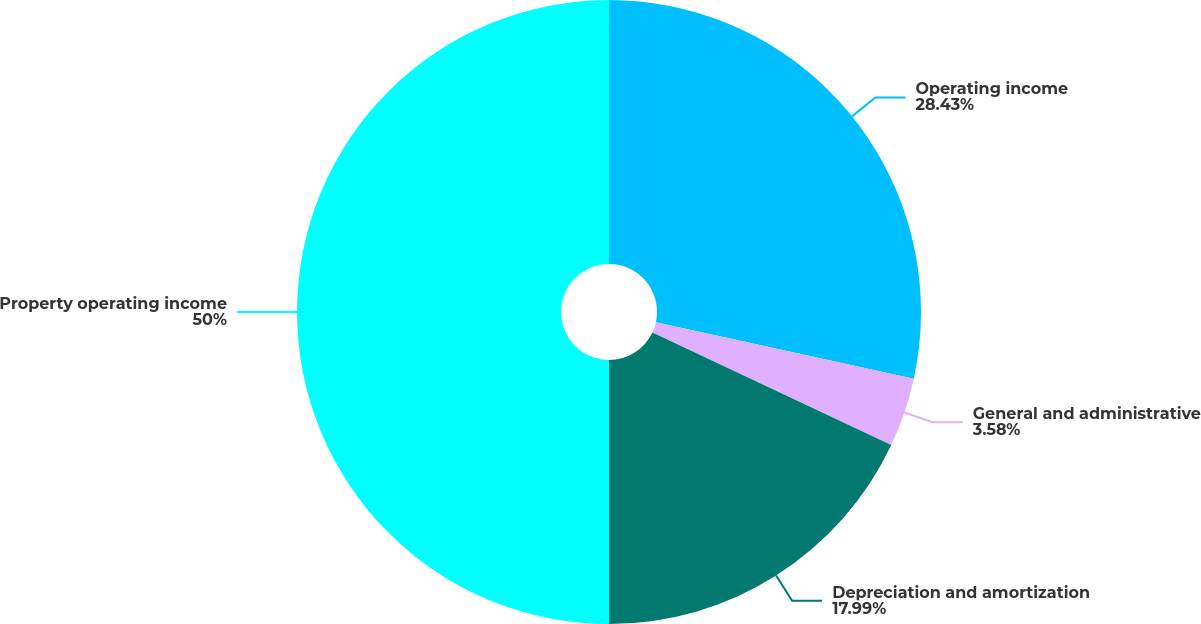Convert chart to OTSL. <chart><loc_0><loc_0><loc_500><loc_500><pie_chart><fcel>Operating income<fcel>General and administrative<fcel>Depreciation and amortization<fcel>Property operating income<nl><fcel>28.43%<fcel>3.58%<fcel>17.99%<fcel>50.0%<nl></chart> 